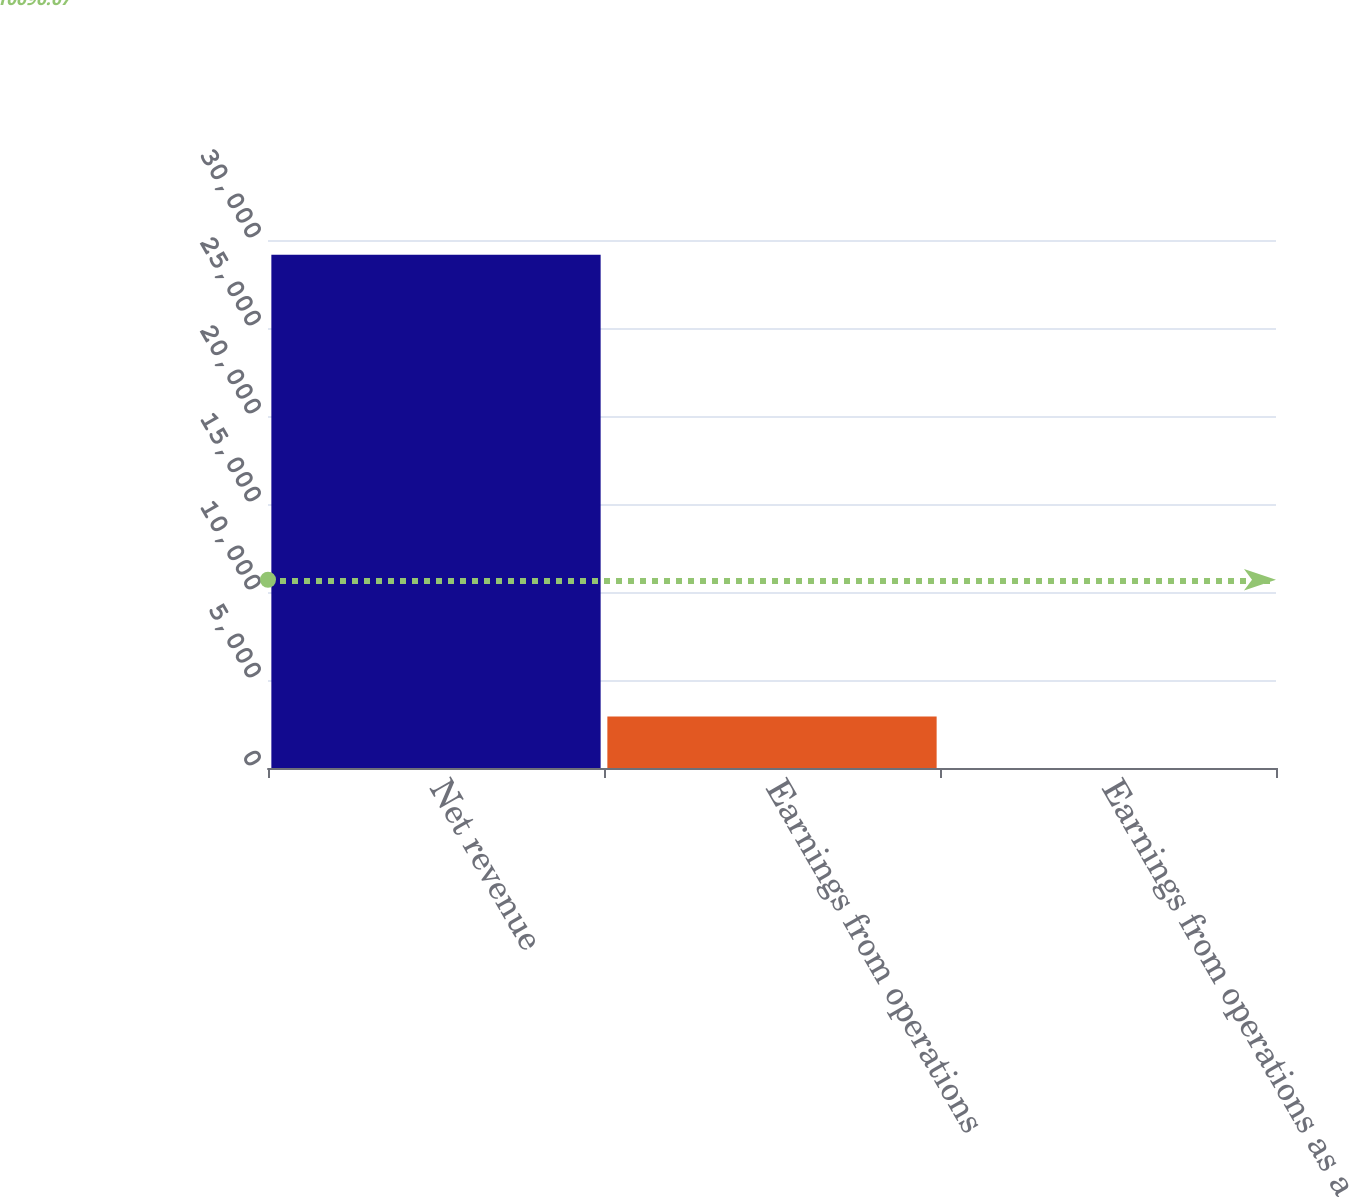Convert chart. <chart><loc_0><loc_0><loc_500><loc_500><bar_chart><fcel>Net revenue<fcel>Earnings from operations<fcel>Earnings from operations as a<nl><fcel>29166<fcel>2920.11<fcel>3.9<nl></chart> 